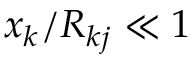Convert formula to latex. <formula><loc_0><loc_0><loc_500><loc_500>x _ { k } / R _ { k j } \ll 1</formula> 